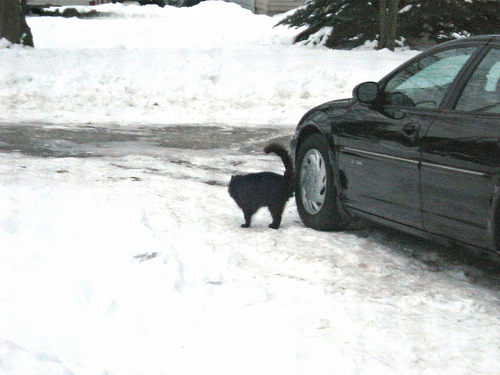<image>
Is the dog to the left of the car? Yes. From this viewpoint, the dog is positioned to the left side relative to the car. Where is the car in relation to the cat? Is it to the left of the cat? No. The car is not to the left of the cat. From this viewpoint, they have a different horizontal relationship. Is there a cat in the car? No. The cat is not contained within the car. These objects have a different spatial relationship. 